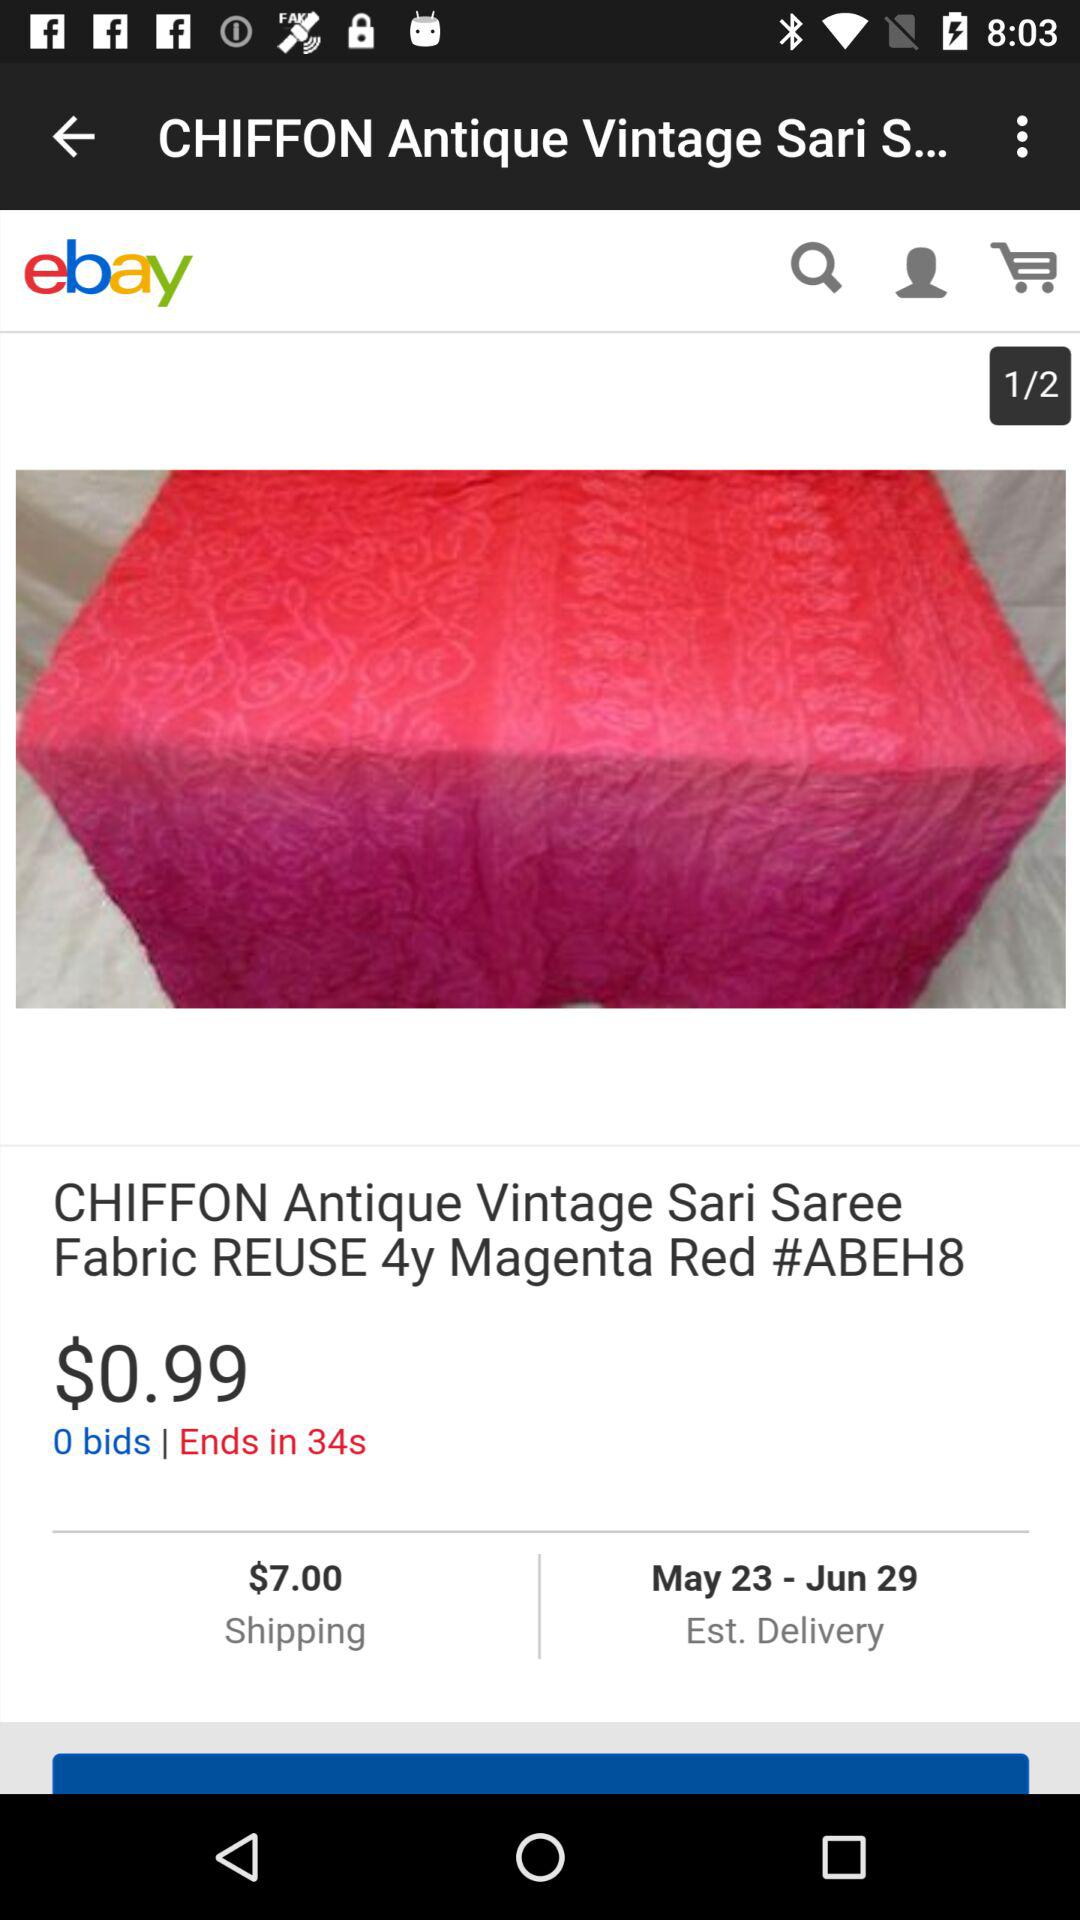What is the shipping price? The shipping price is $7.00. 